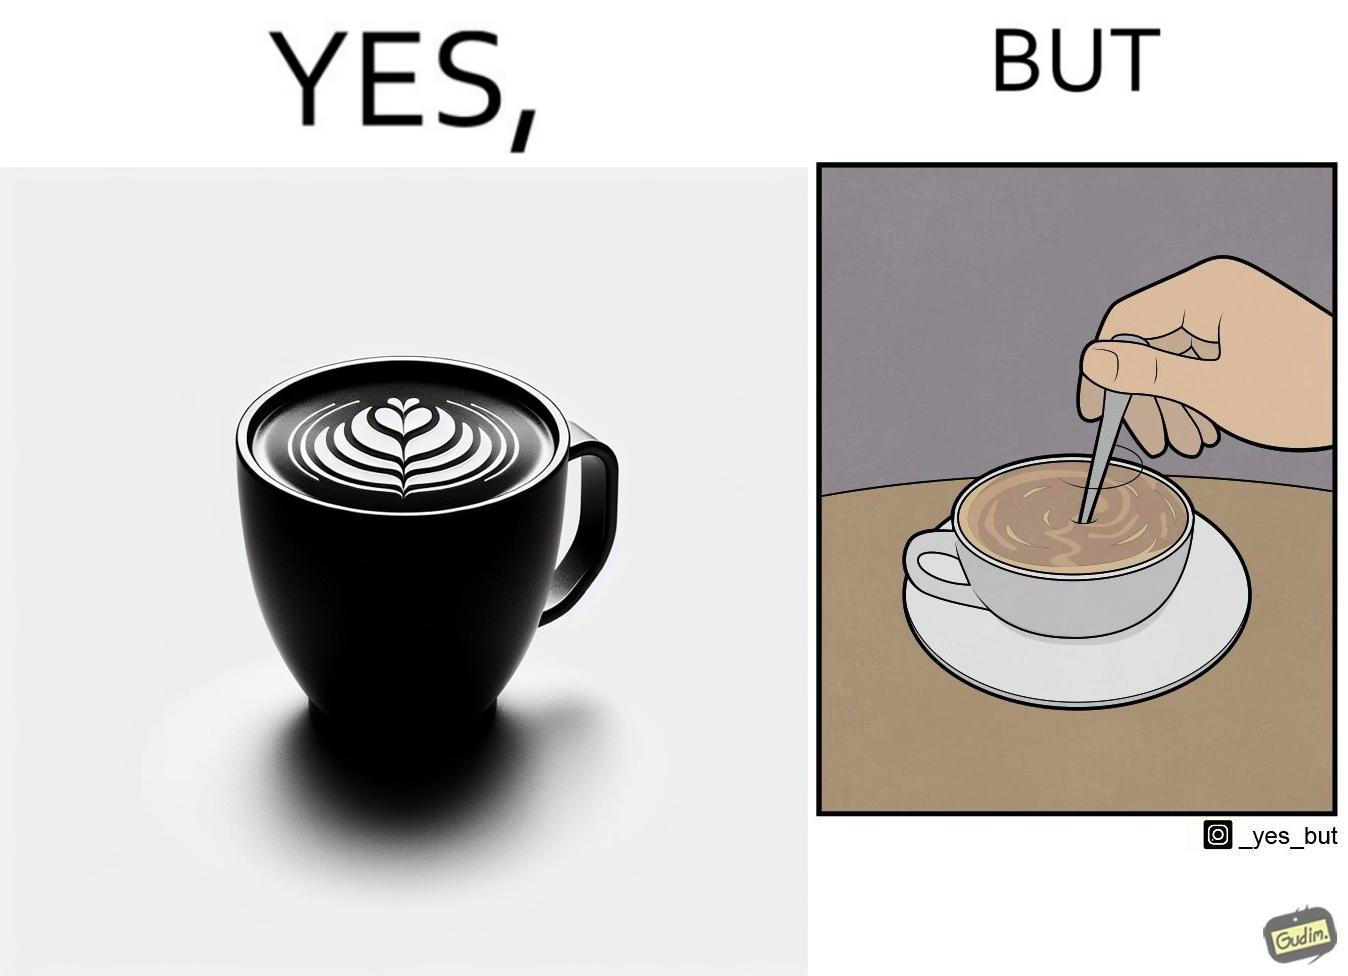What do you see in each half of this image? In the left part of the image: a cup of coffee with latte art on it In the right part of the image: a person stirring the coffee with spoon 